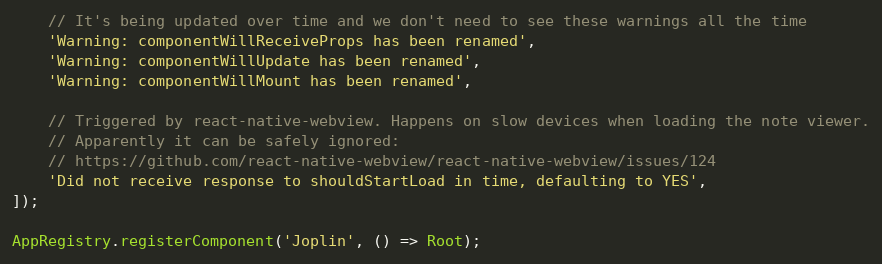<code> <loc_0><loc_0><loc_500><loc_500><_JavaScript_>	// It's being updated over time and we don't need to see these warnings all the time
	'Warning: componentWillReceiveProps has been renamed',
	'Warning: componentWillUpdate has been renamed',
	'Warning: componentWillMount has been renamed',

	// Triggered by react-native-webview. Happens on slow devices when loading the note viewer.
	// Apparently it can be safely ignored:
	// https://github.com/react-native-webview/react-native-webview/issues/124
	'Did not receive response to shouldStartLoad in time, defaulting to YES',
]);

AppRegistry.registerComponent('Joplin', () => Root);
</code> 